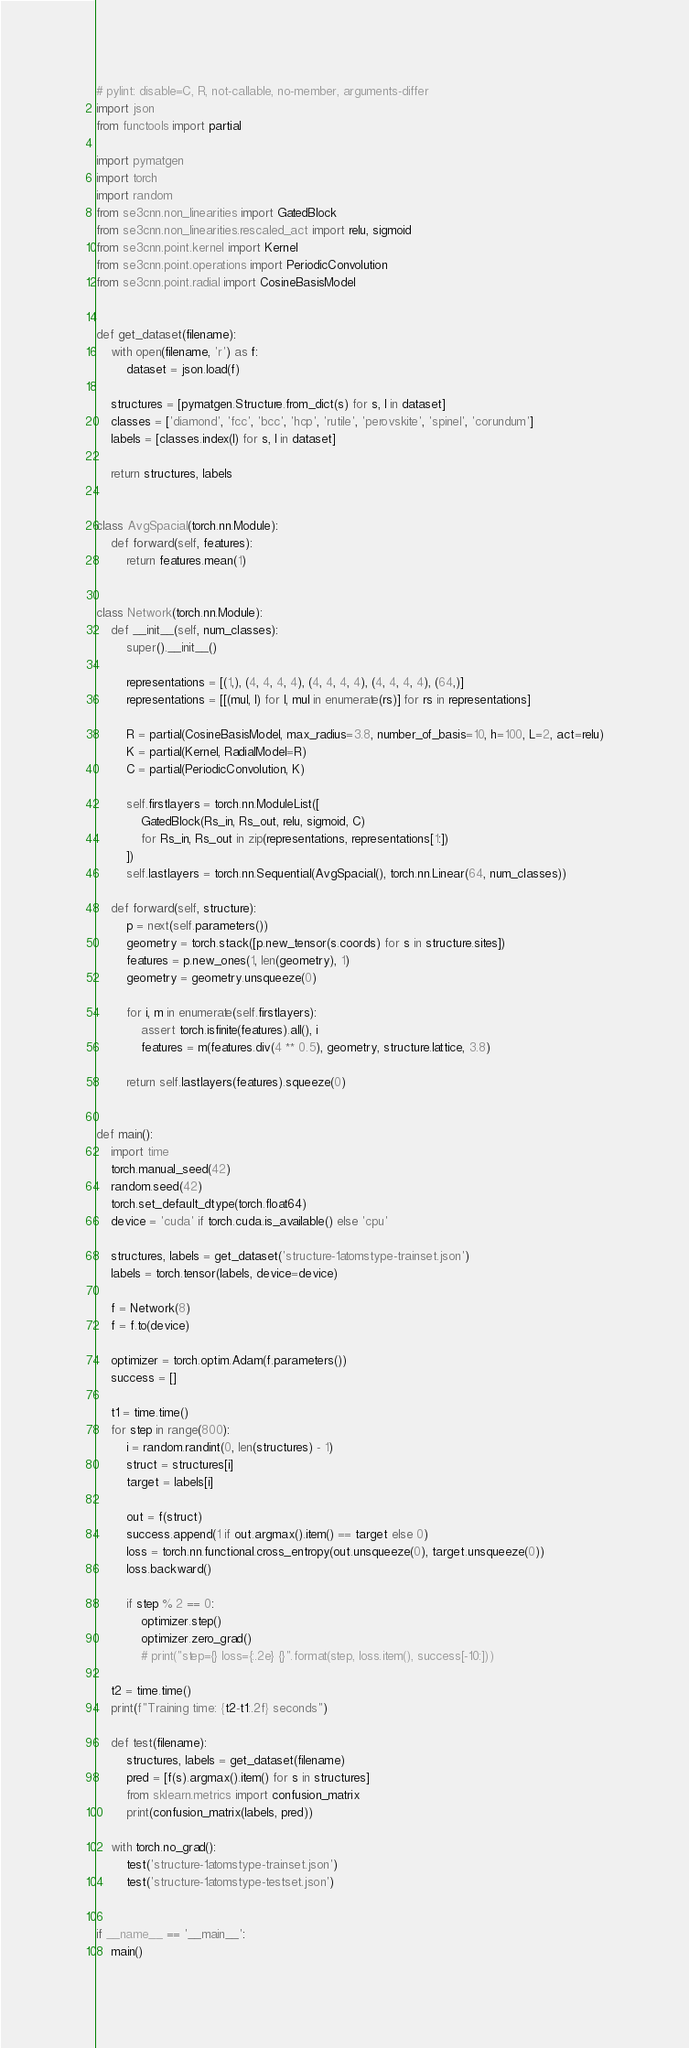Convert code to text. <code><loc_0><loc_0><loc_500><loc_500><_Python_># pylint: disable=C, R, not-callable, no-member, arguments-differ
import json
from functools import partial

import pymatgen
import torch
import random
from se3cnn.non_linearities import GatedBlock
from se3cnn.non_linearities.rescaled_act import relu, sigmoid
from se3cnn.point.kernel import Kernel
from se3cnn.point.operations import PeriodicConvolution
from se3cnn.point.radial import CosineBasisModel


def get_dataset(filename):
    with open(filename, 'r') as f:
        dataset = json.load(f)

    structures = [pymatgen.Structure.from_dict(s) for s, l in dataset]
    classes = ['diamond', 'fcc', 'bcc', 'hcp', 'rutile', 'perovskite', 'spinel', 'corundum']
    labels = [classes.index(l) for s, l in dataset]

    return structures, labels


class AvgSpacial(torch.nn.Module):
    def forward(self, features):
        return features.mean(1)


class Network(torch.nn.Module):
    def __init__(self, num_classes):
        super().__init__()

        representations = [(1,), (4, 4, 4, 4), (4, 4, 4, 4), (4, 4, 4, 4), (64,)]
        representations = [[(mul, l) for l, mul in enumerate(rs)] for rs in representations]

        R = partial(CosineBasisModel, max_radius=3.8, number_of_basis=10, h=100, L=2, act=relu)
        K = partial(Kernel, RadialModel=R)
        C = partial(PeriodicConvolution, K)

        self.firstlayers = torch.nn.ModuleList([
            GatedBlock(Rs_in, Rs_out, relu, sigmoid, C)
            for Rs_in, Rs_out in zip(representations, representations[1:])
        ])
        self.lastlayers = torch.nn.Sequential(AvgSpacial(), torch.nn.Linear(64, num_classes))

    def forward(self, structure):
        p = next(self.parameters())
        geometry = torch.stack([p.new_tensor(s.coords) for s in structure.sites])
        features = p.new_ones(1, len(geometry), 1)
        geometry = geometry.unsqueeze(0)

        for i, m in enumerate(self.firstlayers):
            assert torch.isfinite(features).all(), i
            features = m(features.div(4 ** 0.5), geometry, structure.lattice, 3.8)

        return self.lastlayers(features).squeeze(0)


def main():
    import time
    torch.manual_seed(42)
    random.seed(42)
    torch.set_default_dtype(torch.float64)
    device = 'cuda' if torch.cuda.is_available() else 'cpu'

    structures, labels = get_dataset('structure-1atomstype-trainset.json')
    labels = torch.tensor(labels, device=device)

    f = Network(8)
    f = f.to(device)

    optimizer = torch.optim.Adam(f.parameters())
    success = []

    t1 = time.time()
    for step in range(800):
        i = random.randint(0, len(structures) - 1)
        struct = structures[i]
        target = labels[i]

        out = f(struct)
        success.append(1 if out.argmax().item() == target else 0)
        loss = torch.nn.functional.cross_entropy(out.unsqueeze(0), target.unsqueeze(0))
        loss.backward()

        if step % 2 == 0:
            optimizer.step()
            optimizer.zero_grad()
            # print("step={} loss={:.2e} {}".format(step, loss.item(), success[-10:]))
    
    t2 = time.time()
    print(f"Training time: {t2-t1:.2f} seconds")

    def test(filename):
        structures, labels = get_dataset(filename)
        pred = [f(s).argmax().item() for s in structures]
        from sklearn.metrics import confusion_matrix
        print(confusion_matrix(labels, pred))

    with torch.no_grad():
        test('structure-1atomstype-trainset.json')
        test('structure-1atomstype-testset.json')


if __name__ == '__main__':
    main()
</code> 